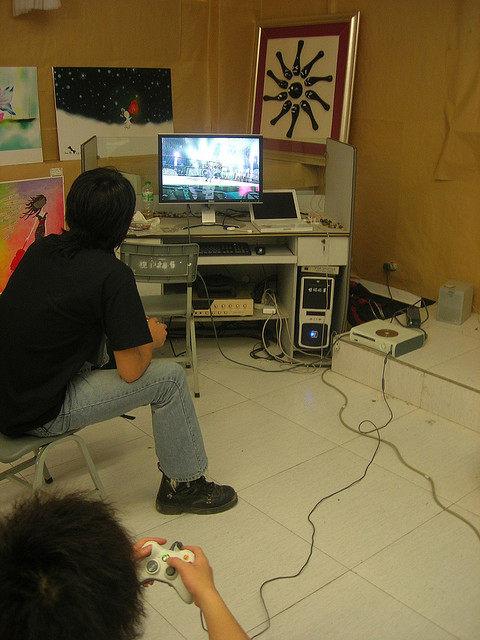Describe the activities taking place. The scene depicts two people immersed in a video game. The individual in the foreground is holding a game controller, clearly focused on the screen. Another person is sitting at a desk, possibly managing the game settings or also participating in the gameplay. The room features a varied decor, with several pieces of artwork on the walls, which adds an artistic vibe to the environment. 